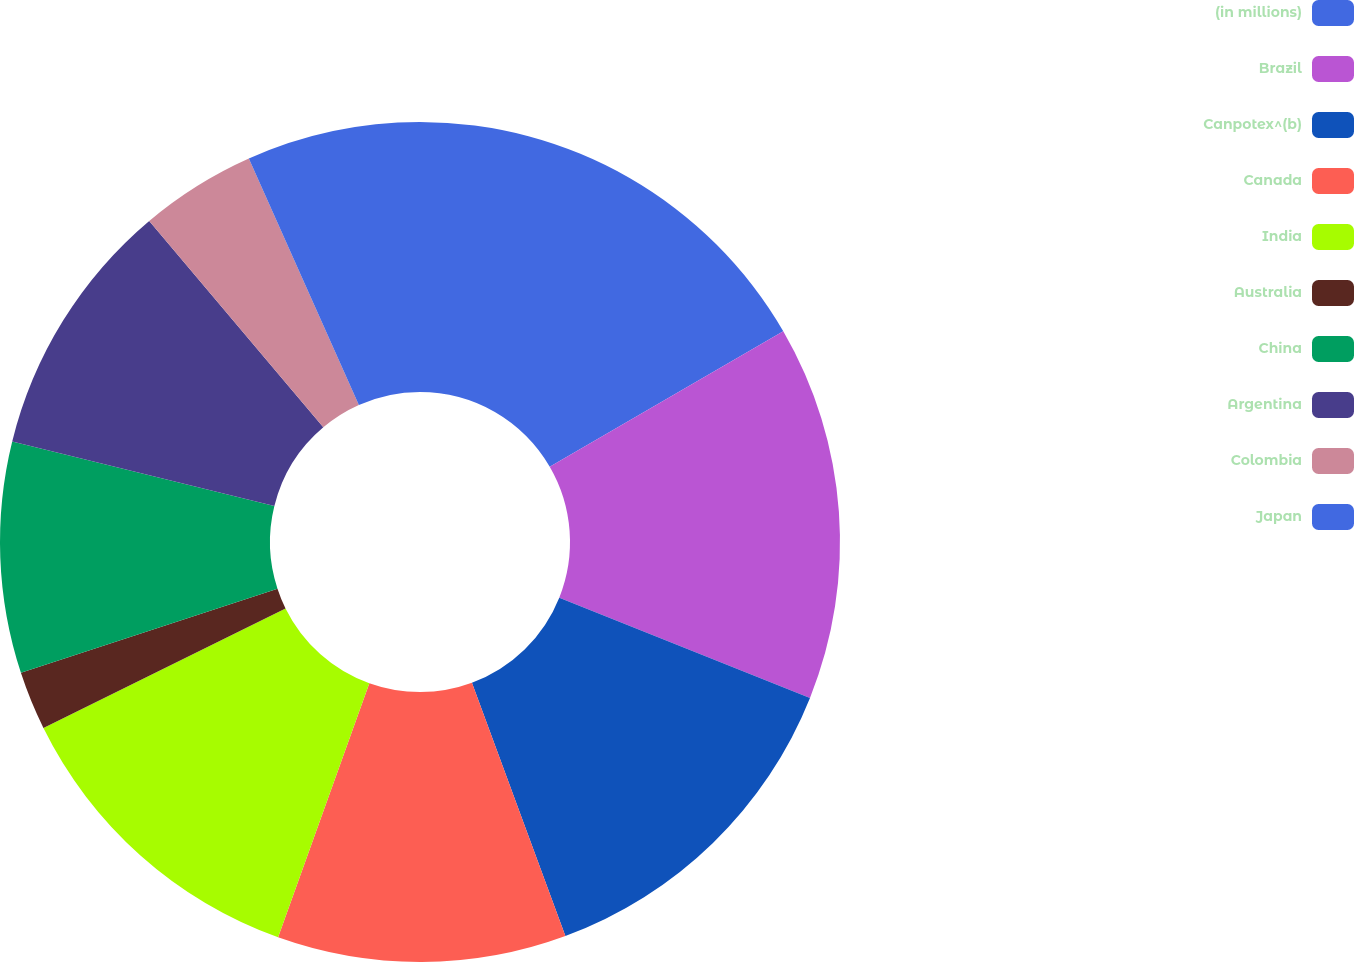Convert chart. <chart><loc_0><loc_0><loc_500><loc_500><pie_chart><fcel>(in millions)<fcel>Brazil<fcel>Canpotex^(b)<fcel>Canada<fcel>India<fcel>Australia<fcel>China<fcel>Argentina<fcel>Colombia<fcel>Japan<nl><fcel>16.63%<fcel>14.42%<fcel>13.32%<fcel>11.11%<fcel>12.21%<fcel>2.26%<fcel>8.89%<fcel>10.0%<fcel>4.47%<fcel>6.68%<nl></chart> 